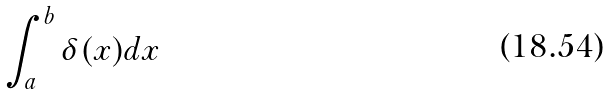<formula> <loc_0><loc_0><loc_500><loc_500>\int _ { a } ^ { b } \delta ( x ) d x</formula> 